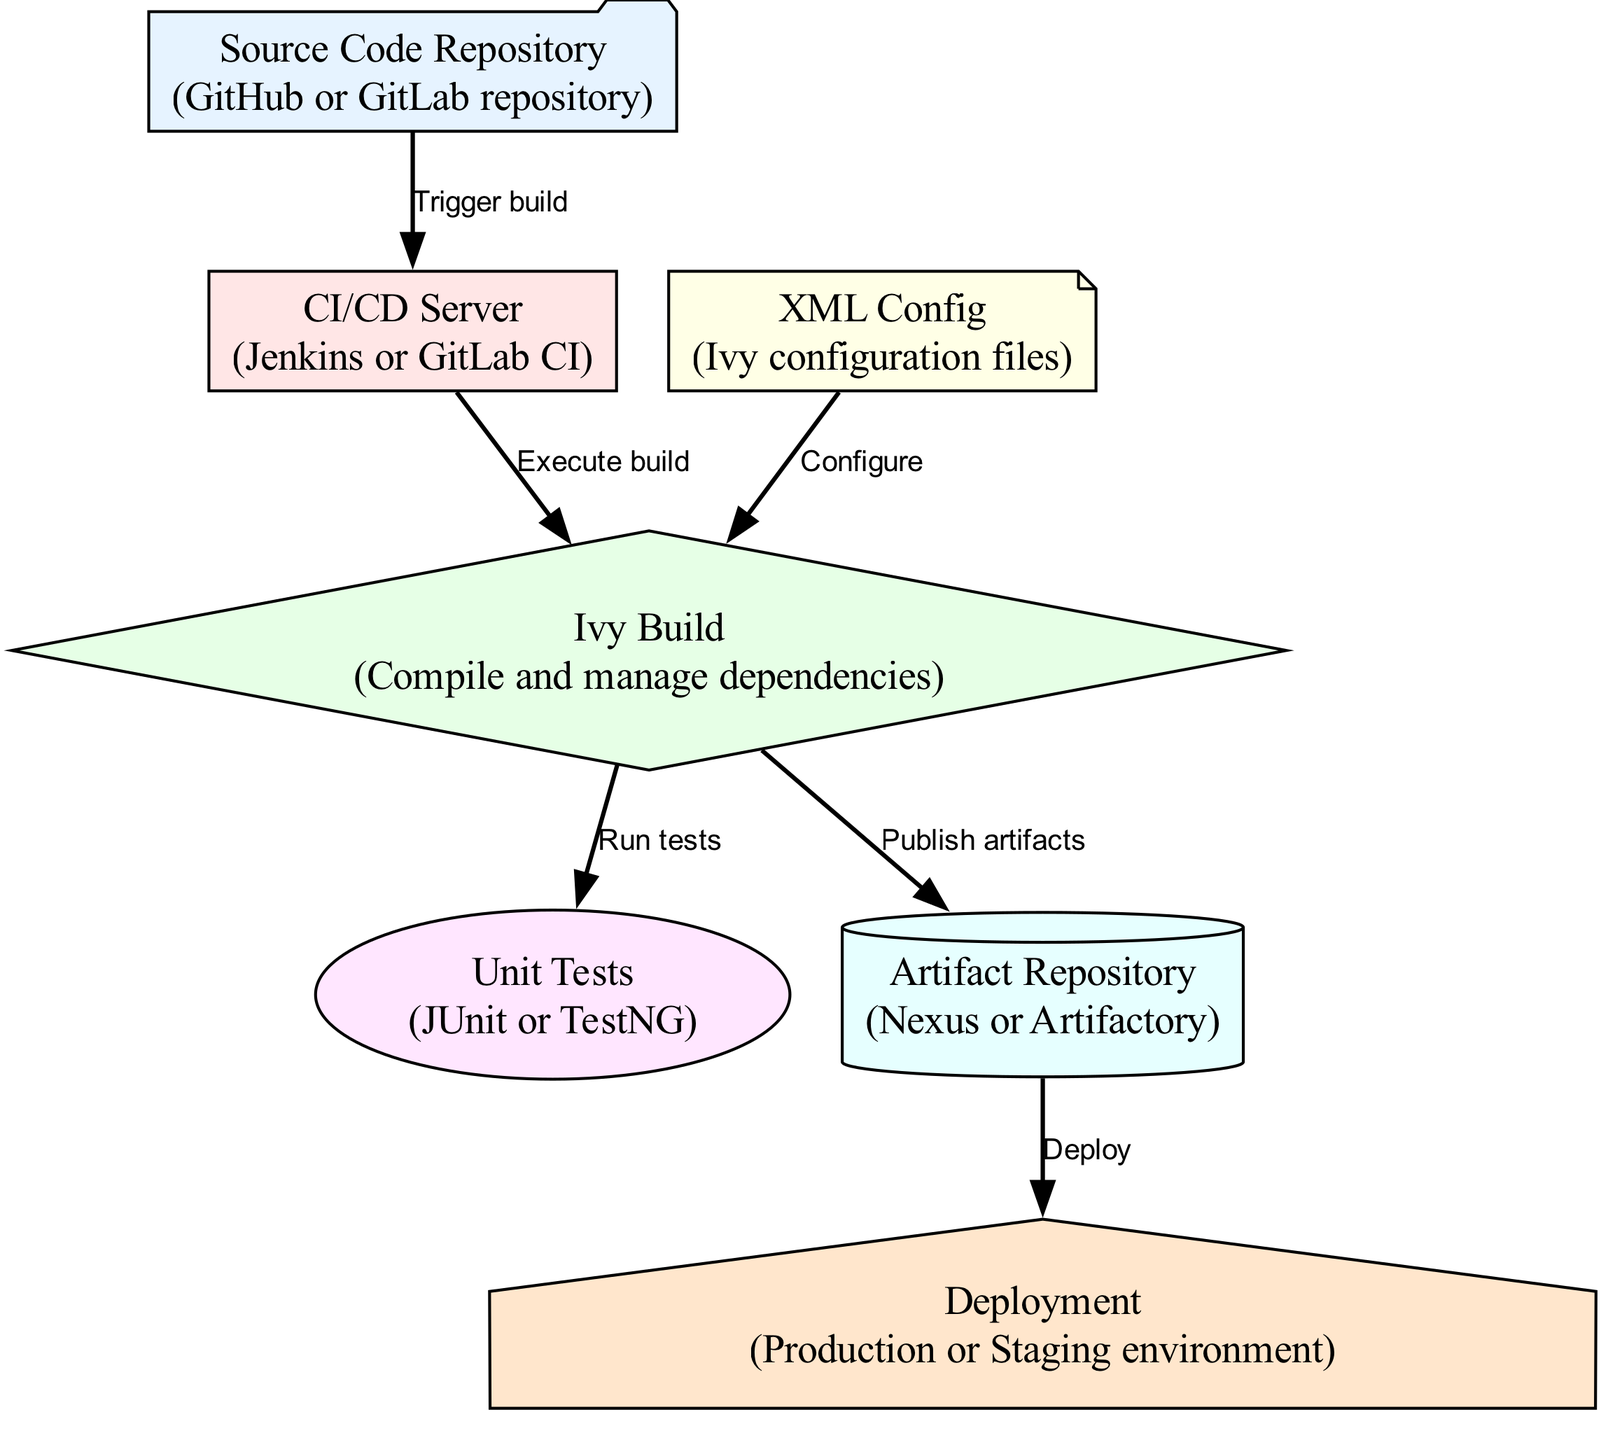What is the first node in the diagram? The first node in the diagram is the "Source Code Repository." It represents where the source code is stored, indicated by its position at the top and its labeling.
Answer: Source Code Repository How many edges are in the diagram? The diagram contains six edges. This is identified by counting all the arrows connecting nodes, which represent the flow of information or actions in the CI/CD pipeline.
Answer: Six What does the CI/CD Server do? The CI/CD Server executes the build. This is evident from the directed edge going from "CI/CD Server" to "Ivy Build," which indicates that the CI/CD server's purpose is to trigger the build process.
Answer: Execute build Which node follows the Ivy Build in the flow? The node that follows the Ivy Build in the flow is "Unit Tests." This can be seen in the directed edge from "Ivy Build" pointing to "Unit Tests," showing the order of operations in the CI/CD pipeline.
Answer: Unit Tests Where do the artifacts get published? The artifacts get published to the "Artifact Repository." This is clear from the directed edge going from "Ivy Build" to "Artifact Repository," indicating where the output of the build process is stored.
Answer: Artifact Repository What is the final destination node in the pipeline? The final destination node in the pipeline is "Deployment." This is answered by identifying that the last arrow points to the "Deployment" node, indicating the completion of the CI/CD process.
Answer: Deployment Which node is associated with XML configuration? The node associated with XML configuration is "XML Config." The relationship is established via the edge that leads from "XML Config" to "Ivy Build," indicating its role in configuring the build process.
Answer: XML Config What action happens after running the tests? After running the tests, the action that happens is "Publish artifacts." This is determined by the flow, where once the tests are complete, the artifacts derived from the build are published to the repository.
Answer: Publish artifacts 